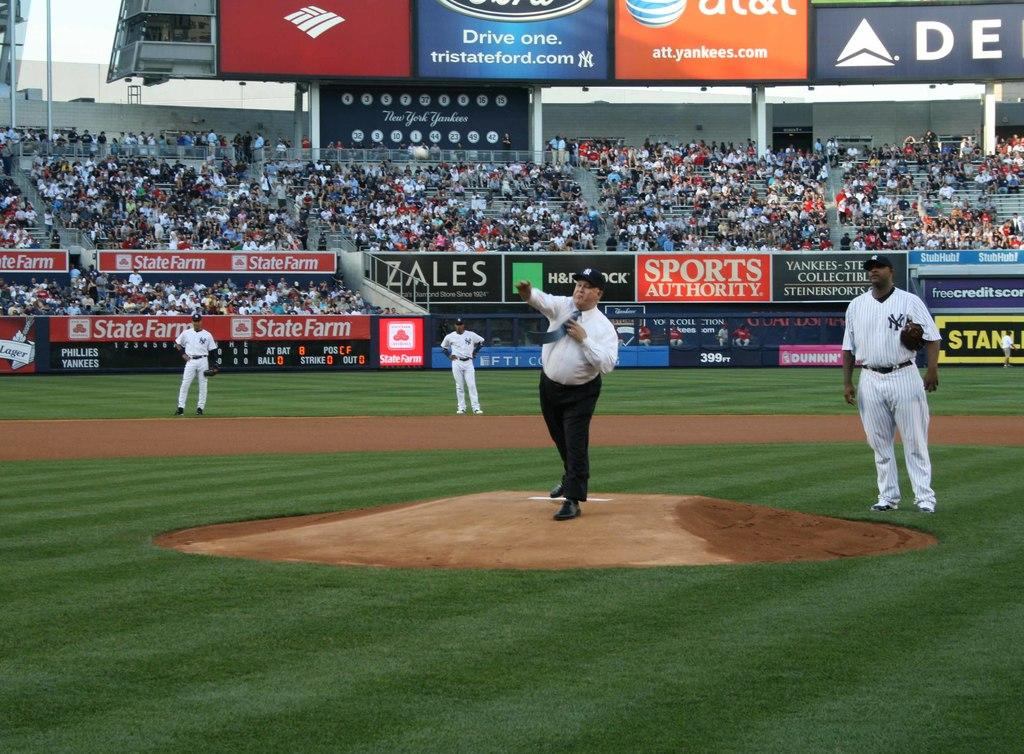<image>
Write a terse but informative summary of the picture. a baseball stadium with players wearing the NY yankees uniforms 